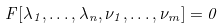Convert formula to latex. <formula><loc_0><loc_0><loc_500><loc_500>F [ \lambda _ { 1 } , \dots , \lambda _ { n } , \nu _ { 1 } , \dots , \nu _ { m } ] = 0</formula> 